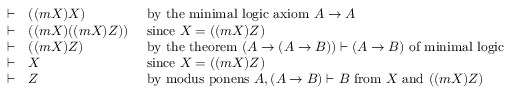<formula> <loc_0><loc_0><loc_500><loc_500>{ \begin{array} { c l l } { \vdash } & { ( ( m X ) X ) } & { { b y t h e \min i m a l \log i c a x i o m } A \to A } \\ { \vdash } & { ( ( m X ) ( ( m X ) Z ) ) } & { { \sin c e } X = ( ( m X ) Z ) } \\ { \vdash } & { ( ( m X ) Z ) } & { { b y t h e t h e o r e m } ( A \to ( A \to B ) ) \vdash ( A \to B ) { o f \min i m a l \log i c } } \\ { \vdash } & { X } & { { \sin c e } X = ( ( m X ) Z ) } \\ { \vdash } & { Z } & { { b y m o d u s p o n e n s } A , ( A \to B ) \vdash B { f r o m } X { a n d } ( ( m X ) Z ) } \end{array} }</formula> 